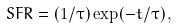<formula> <loc_0><loc_0><loc_500><loc_500>S F R = ( 1 / \tau ) \exp ( - t / \tau ) \, ,</formula> 